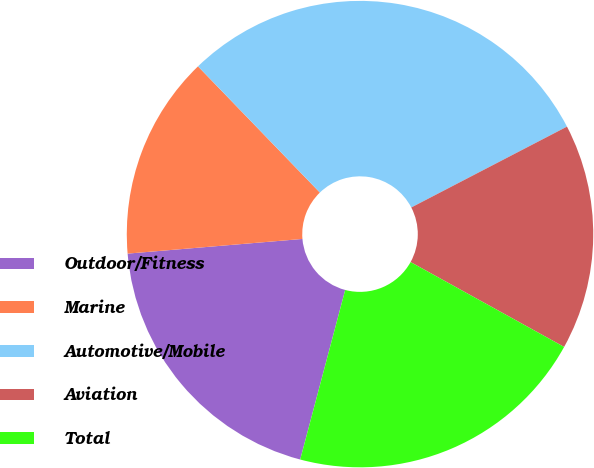<chart> <loc_0><loc_0><loc_500><loc_500><pie_chart><fcel>Outdoor/Fitness<fcel>Marine<fcel>Automotive/Mobile<fcel>Aviation<fcel>Total<nl><fcel>19.54%<fcel>14.11%<fcel>29.6%<fcel>15.66%<fcel>21.09%<nl></chart> 